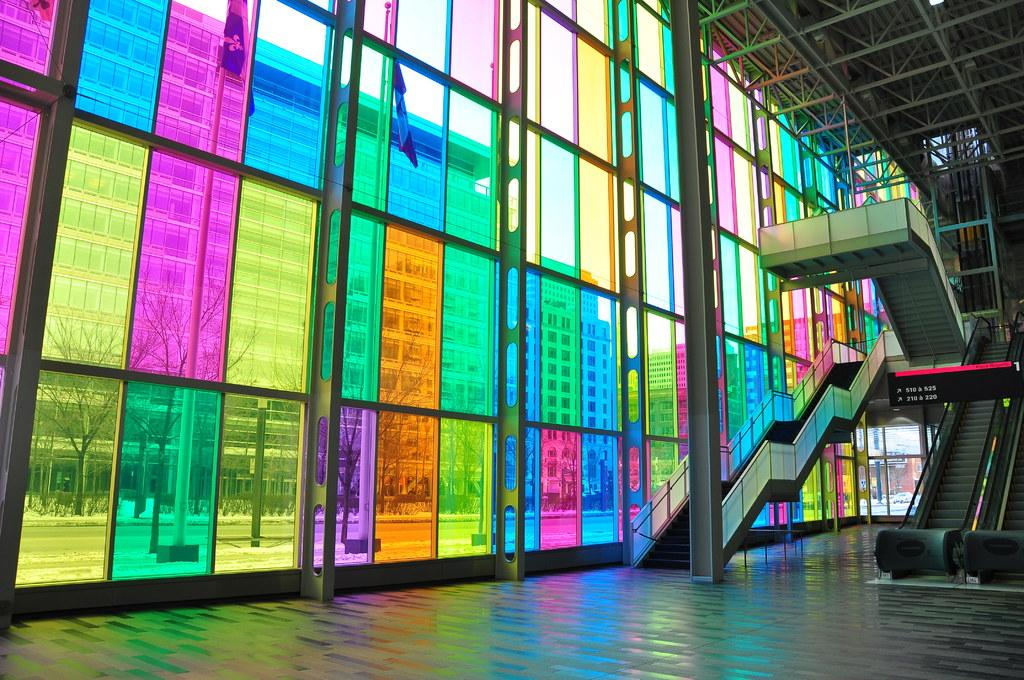What type of structure is present in the image for vertical movement? There are stairs and escalators in the image for vertical movement. What is the purpose of the escalators in the image? The escalators in the image are for climbing up. What can be observed on the buildings in the image? There are different color glasses on the buildings, and other buildings are visible through the glasses. What type of natural element is present in the image? Trees are present in the image. What type of sound can be heard coming from the fairies in the image? There are no fairies present in the image, so it's not possible to determine what, if any, sounds might be heard. What type of work is the laborer doing in the image? There is no laborer present in the image, so it's not possible to determine what work they might be doing. 